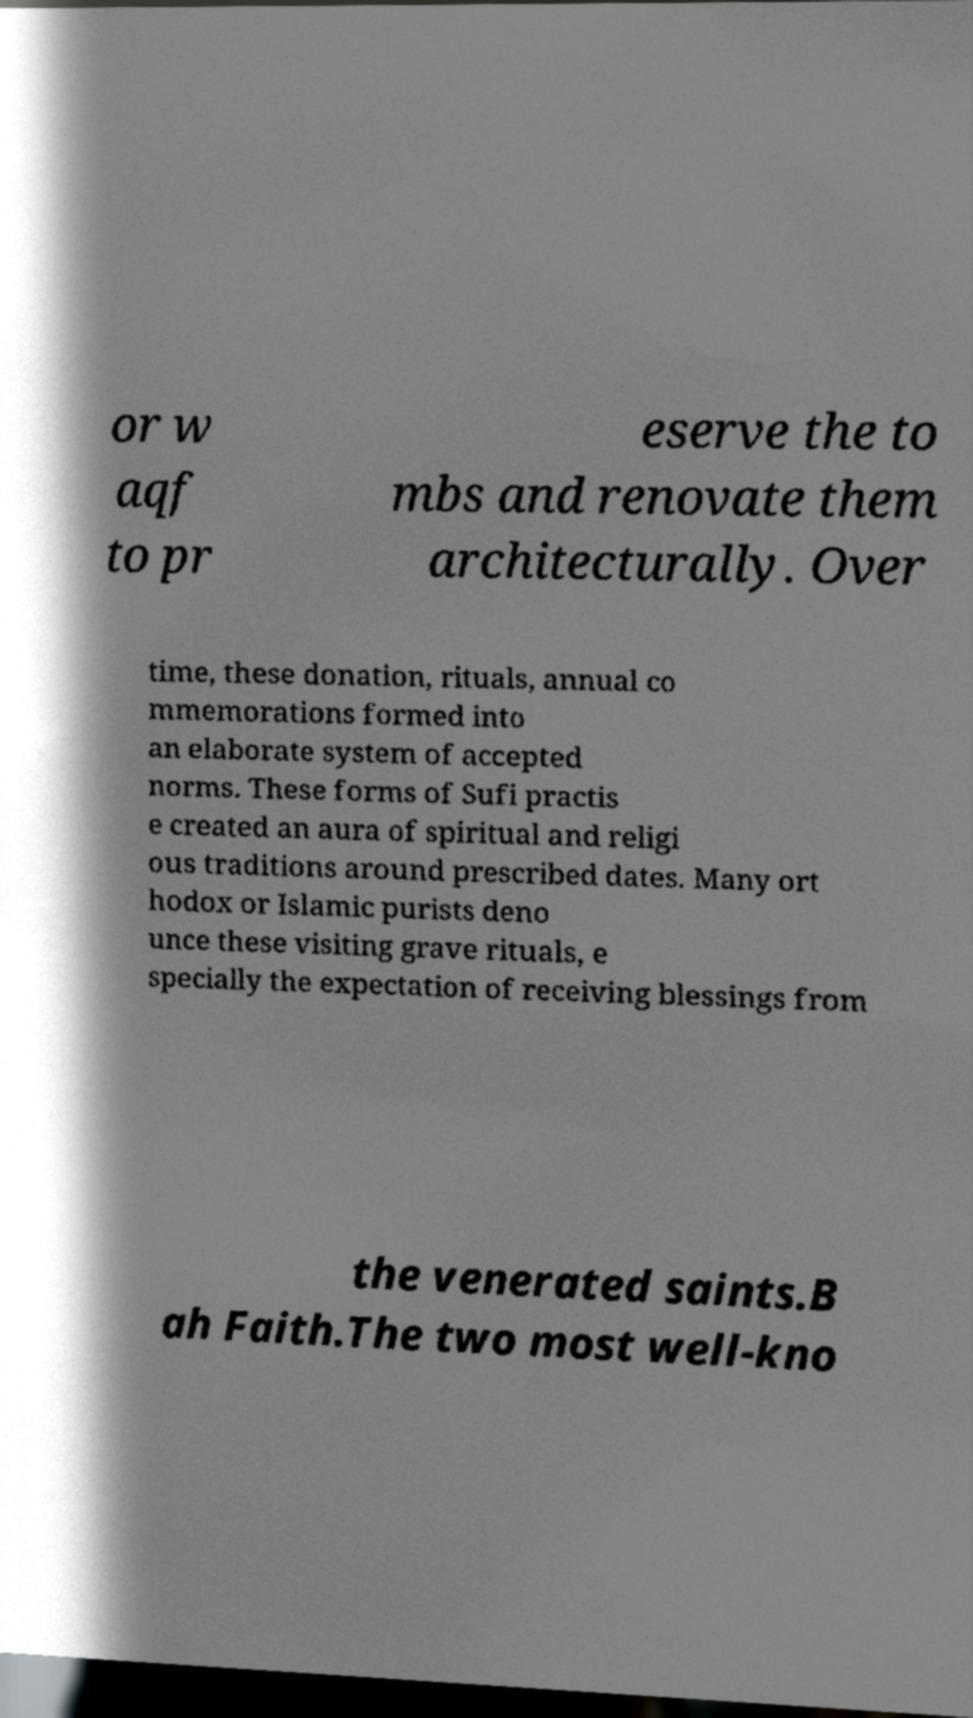Please identify and transcribe the text found in this image. or w aqf to pr eserve the to mbs and renovate them architecturally. Over time, these donation, rituals, annual co mmemorations formed into an elaborate system of accepted norms. These forms of Sufi practis e created an aura of spiritual and religi ous traditions around prescribed dates. Many ort hodox or Islamic purists deno unce these visiting grave rituals, e specially the expectation of receiving blessings from the venerated saints.B ah Faith.The two most well-kno 